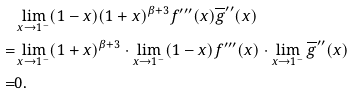<formula> <loc_0><loc_0><loc_500><loc_500>& \lim _ { x \rightarrow 1 ^ { - } } ( 1 - x ) ( 1 + x ) ^ { \beta + 3 } f ^ { \prime \prime \prime } ( x ) \overline { g } ^ { \prime \prime } ( x ) \\ = & \lim _ { x \rightarrow 1 ^ { - } } ( 1 + x ) ^ { \beta + 3 } \cdot \lim _ { x \rightarrow 1 ^ { - } } ( 1 - x ) f ^ { \prime \prime \prime } ( x ) \cdot \lim _ { x \rightarrow 1 ^ { - } } \overline { g } ^ { \prime \prime } ( x ) \\ = & 0 .</formula> 